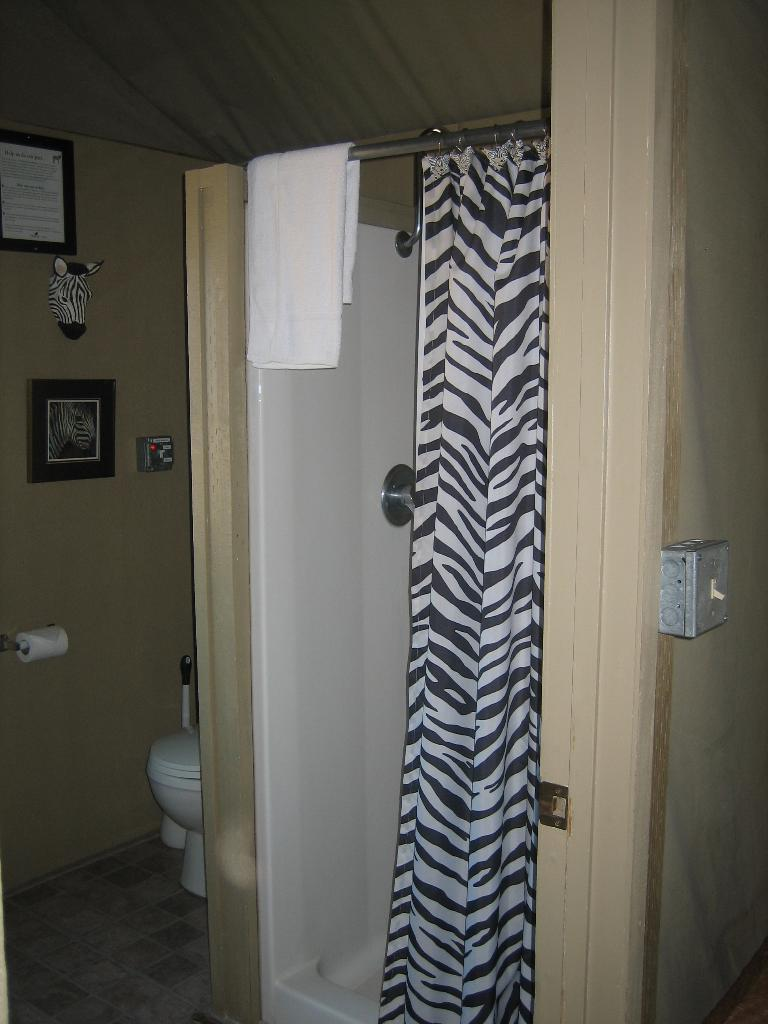What type of room is depicted in the image? The image appears to depict a washroom. What can be seen hanging in the washroom? There is a towel and a curtain in the image. What is the primary fixture in a washroom? There is a toilet seat in the image. What is used for wiping in the washroom? There is toilet paper in the image. What decorative items are present in the washroom? There are photo frames in the image. Can you describe any other objects in the washroom? There are other unspecified objects in the image. How does the achiever make their payment for using the washroom in the image? There is no mention of an achiever or payment in the image; it depicts a washroom with various fixtures and objects. What type of game is being played in the washroom in the image? There is no game being played in the washroom in the image; it is a functional room with no recreational elements. 